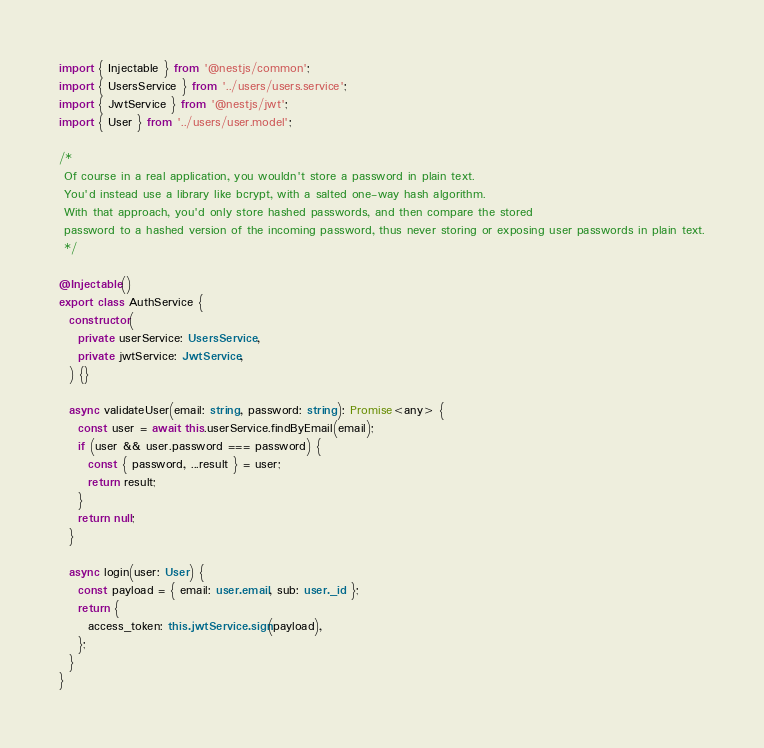Convert code to text. <code><loc_0><loc_0><loc_500><loc_500><_TypeScript_>import { Injectable } from '@nestjs/common';
import { UsersService } from '../users/users.service';
import { JwtService } from '@nestjs/jwt';
import { User } from '../users/user.model';

/*
 Of course in a real application, you wouldn't store a password in plain text.
 You'd instead use a library like bcrypt, with a salted one-way hash algorithm.
 With that approach, you'd only store hashed passwords, and then compare the stored
 password to a hashed version of the incoming password, thus never storing or exposing user passwords in plain text.
 */

@Injectable()
export class AuthService {
  constructor(
    private userService: UsersService,
    private jwtService: JwtService,
  ) {}

  async validateUser(email: string, password: string): Promise<any> {
    const user = await this.userService.findByEmail(email);
    if (user && user.password === password) {
      const { password, ...result } = user;
      return result;
    }
    return null;
  }

  async login(user: User) {
    const payload = { email: user.email, sub: user._id };
    return {
      access_token: this.jwtService.sign(payload),
    };
  }
}
</code> 